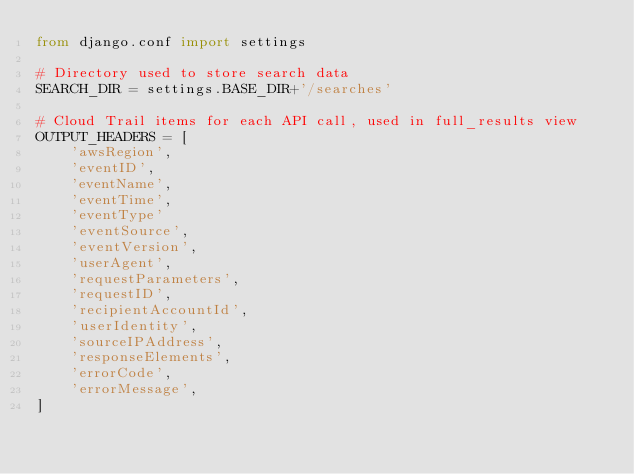Convert code to text. <code><loc_0><loc_0><loc_500><loc_500><_Python_>from django.conf import settings

# Directory used to store search data
SEARCH_DIR = settings.BASE_DIR+'/searches'

# Cloud Trail items for each API call, used in full_results view
OUTPUT_HEADERS = [
    'awsRegion',
    'eventID',
    'eventName',
    'eventTime',
    'eventType'
    'eventSource',
    'eventVersion',
    'userAgent',
    'requestParameters',
    'requestID',
    'recipientAccountId',
    'userIdentity',
    'sourceIPAddress',
    'responseElements',
    'errorCode',
    'errorMessage',
]
</code> 